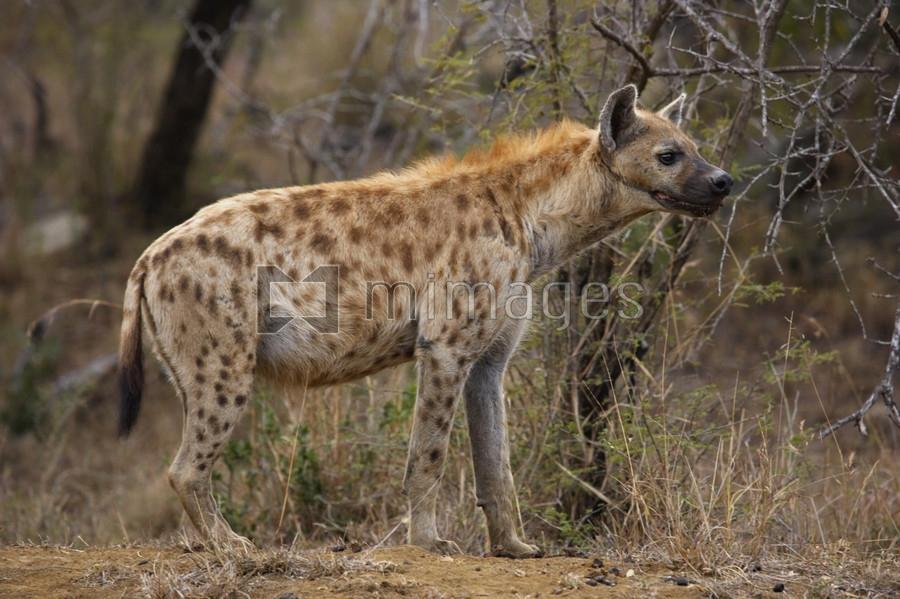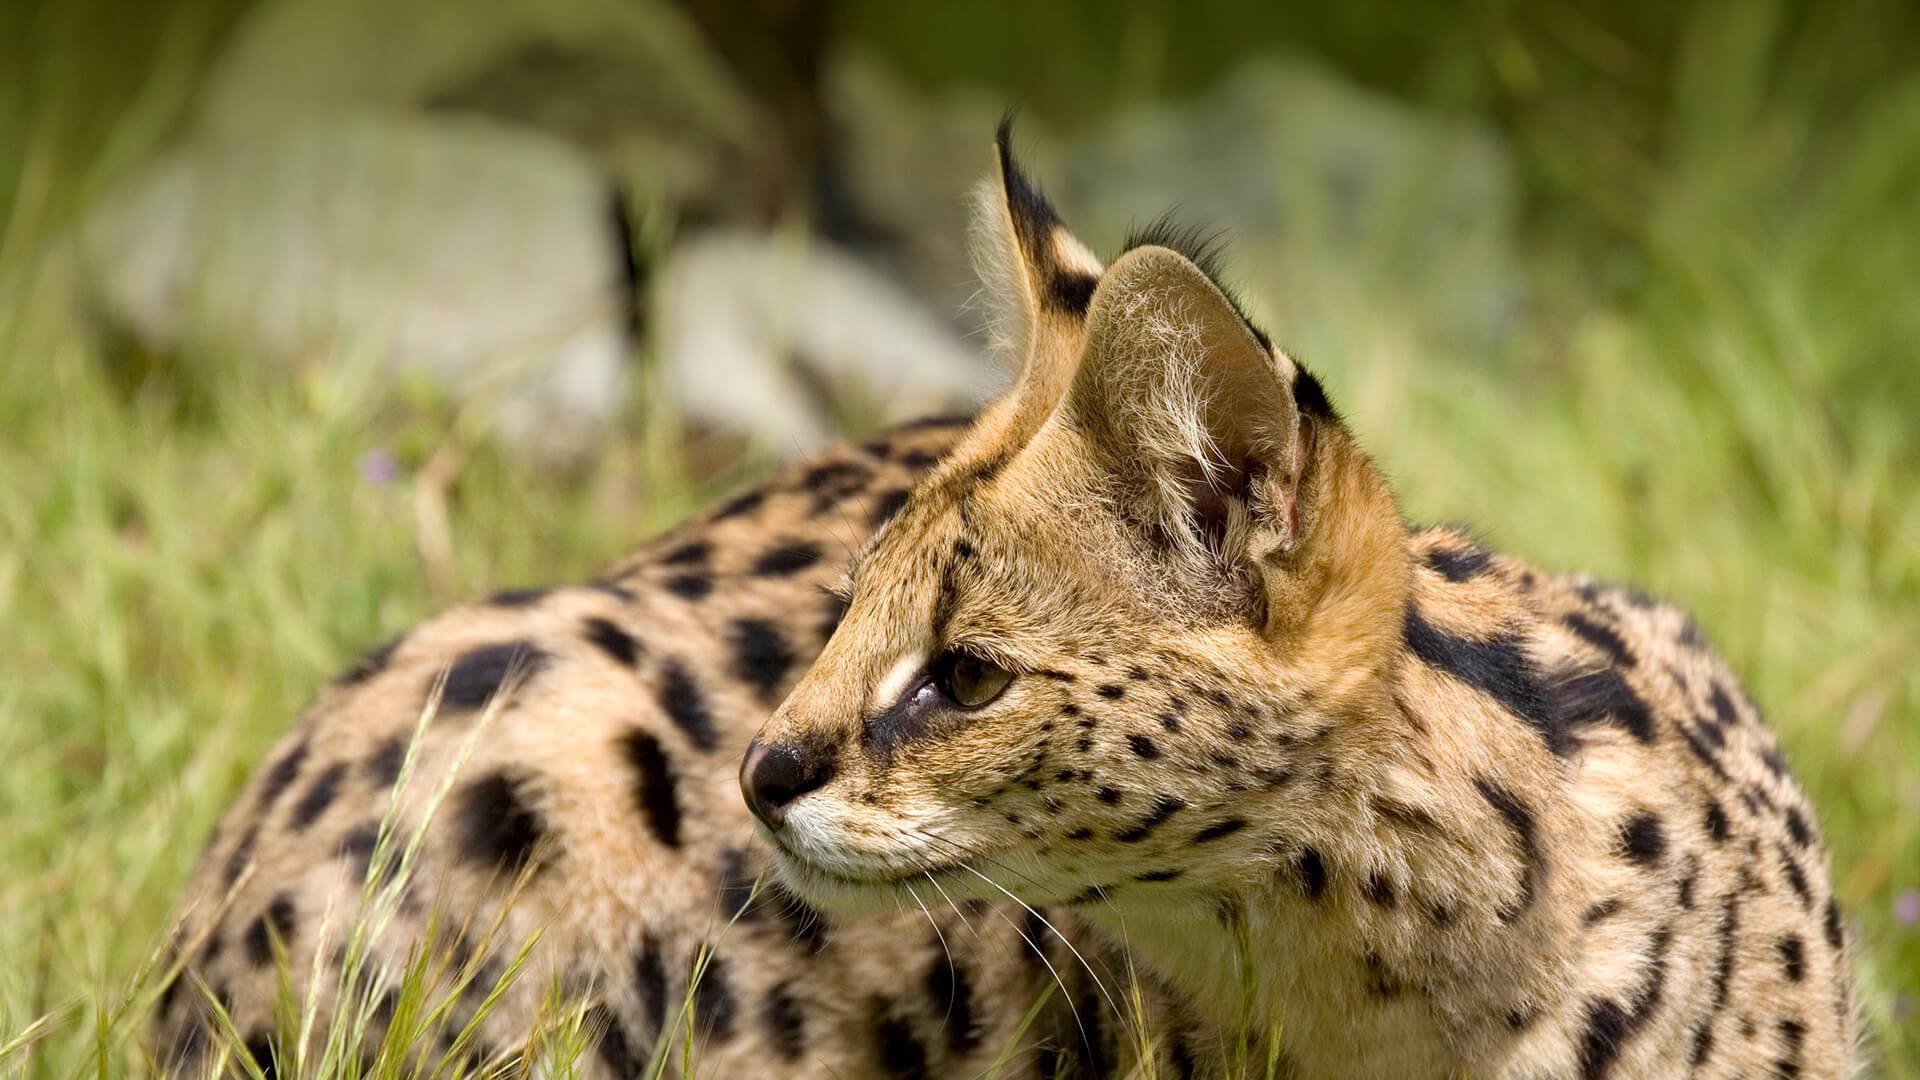The first image is the image on the left, the second image is the image on the right. For the images displayed, is the sentence "There is at least one hyena with its mouth closed." factually correct? Answer yes or no. Yes. The first image is the image on the left, the second image is the image on the right. Considering the images on both sides, is "The left image contains no more than two hyenas." valid? Answer yes or no. Yes. 